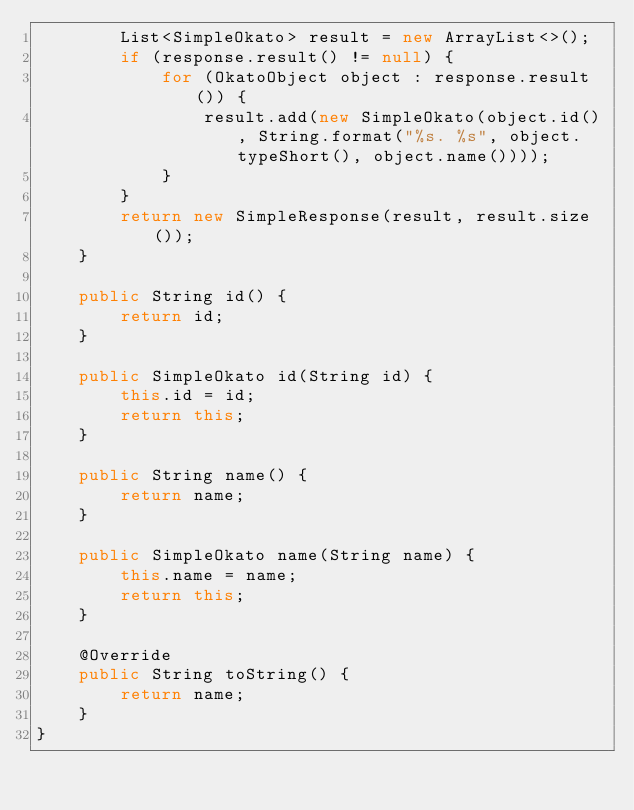<code> <loc_0><loc_0><loc_500><loc_500><_Java_>        List<SimpleOkato> result = new ArrayList<>();
        if (response.result() != null) {
            for (OkatoObject object : response.result()) {
                result.add(new SimpleOkato(object.id(), String.format("%s. %s", object.typeShort(), object.name())));
            }
        }
        return new SimpleResponse(result, result.size());
    }

    public String id() {
        return id;
    }

    public SimpleOkato id(String id) {
        this.id = id;
        return this;
    }

    public String name() {
        return name;
    }

    public SimpleOkato name(String name) {
        this.name = name;
        return this;
    }

    @Override
    public String toString() {
        return name;
    }
}
</code> 